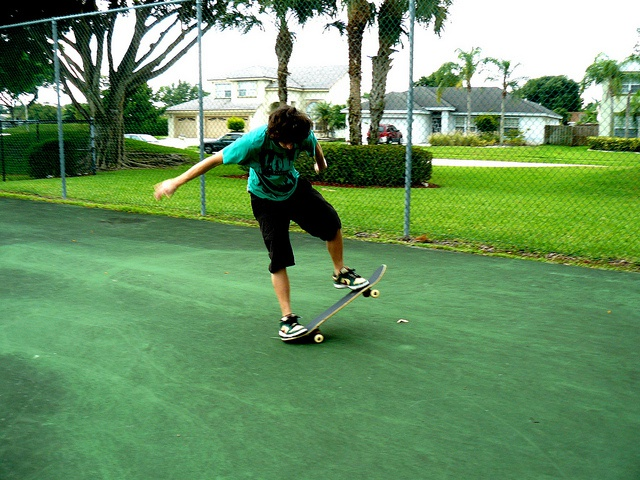Describe the objects in this image and their specific colors. I can see people in black, green, ivory, and olive tones, skateboard in black, gray, green, and olive tones, car in black, gray, maroon, and darkgray tones, and car in black, teal, and white tones in this image. 